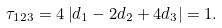Convert formula to latex. <formula><loc_0><loc_0><loc_500><loc_500>\tau _ { 1 2 3 } = 4 \left | d _ { 1 } - 2 d _ { 2 } + 4 d _ { 3 } \right | = 1 .</formula> 